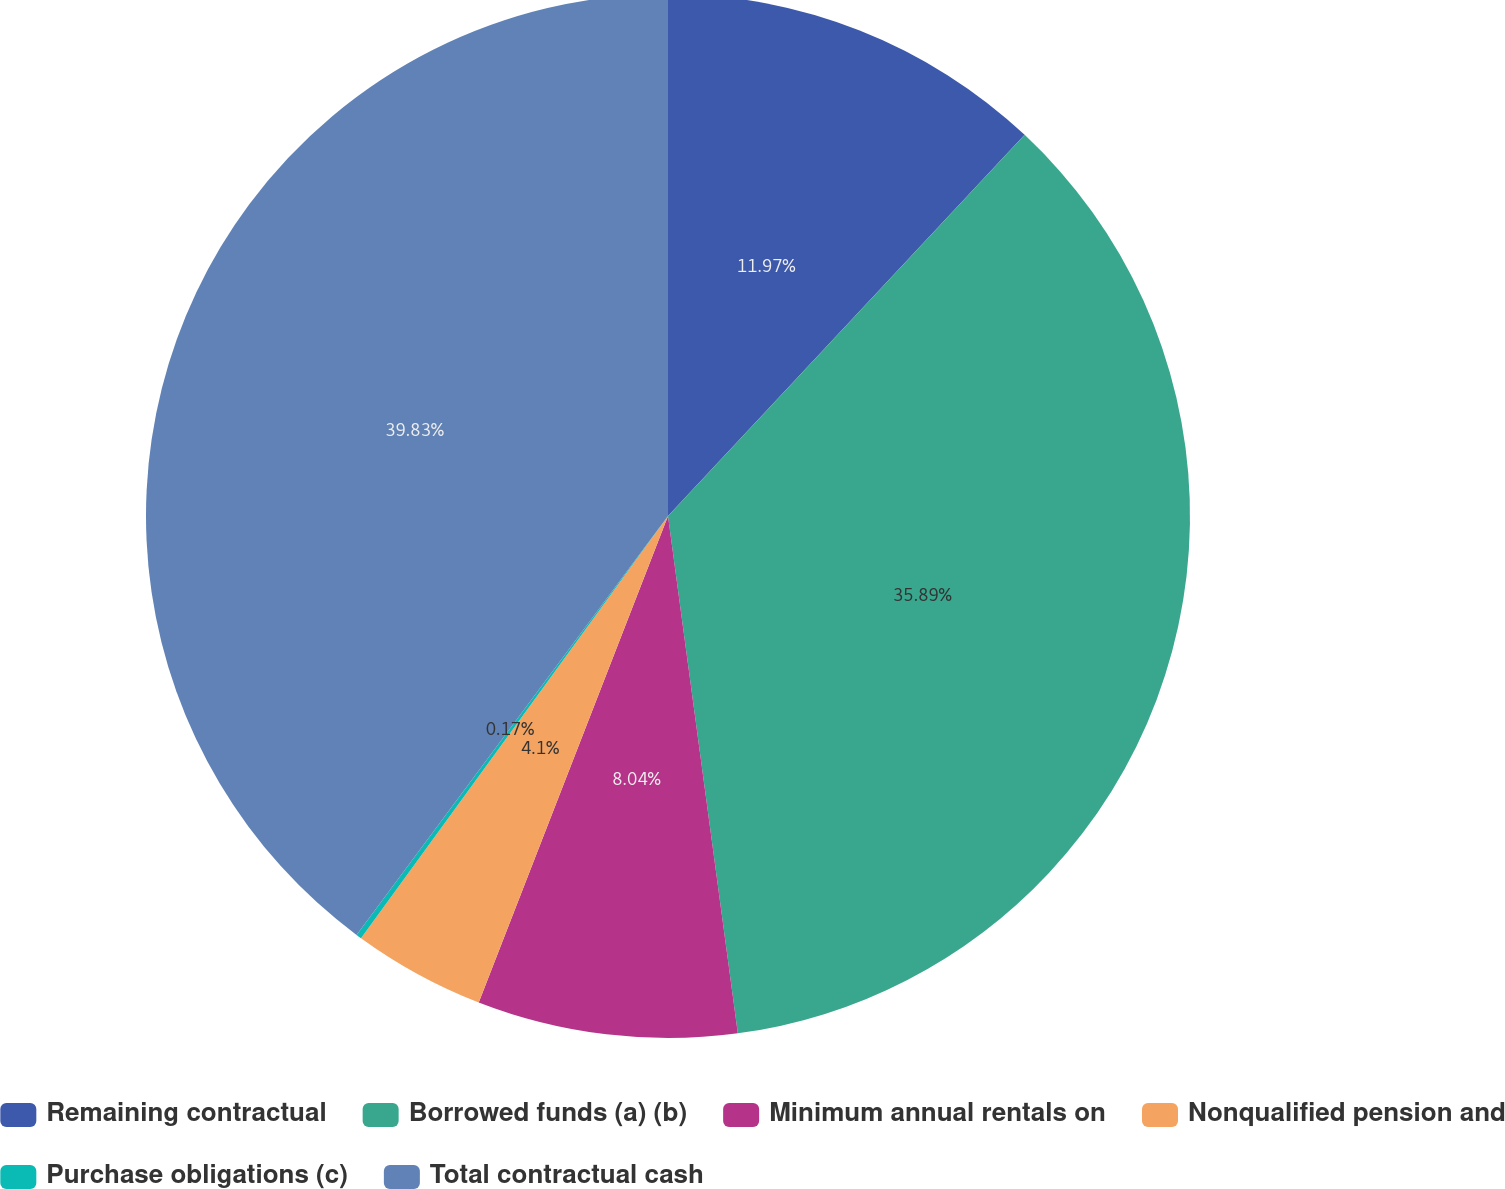Convert chart. <chart><loc_0><loc_0><loc_500><loc_500><pie_chart><fcel>Remaining contractual<fcel>Borrowed funds (a) (b)<fcel>Minimum annual rentals on<fcel>Nonqualified pension and<fcel>Purchase obligations (c)<fcel>Total contractual cash<nl><fcel>11.97%<fcel>35.89%<fcel>8.04%<fcel>4.1%<fcel>0.17%<fcel>39.82%<nl></chart> 